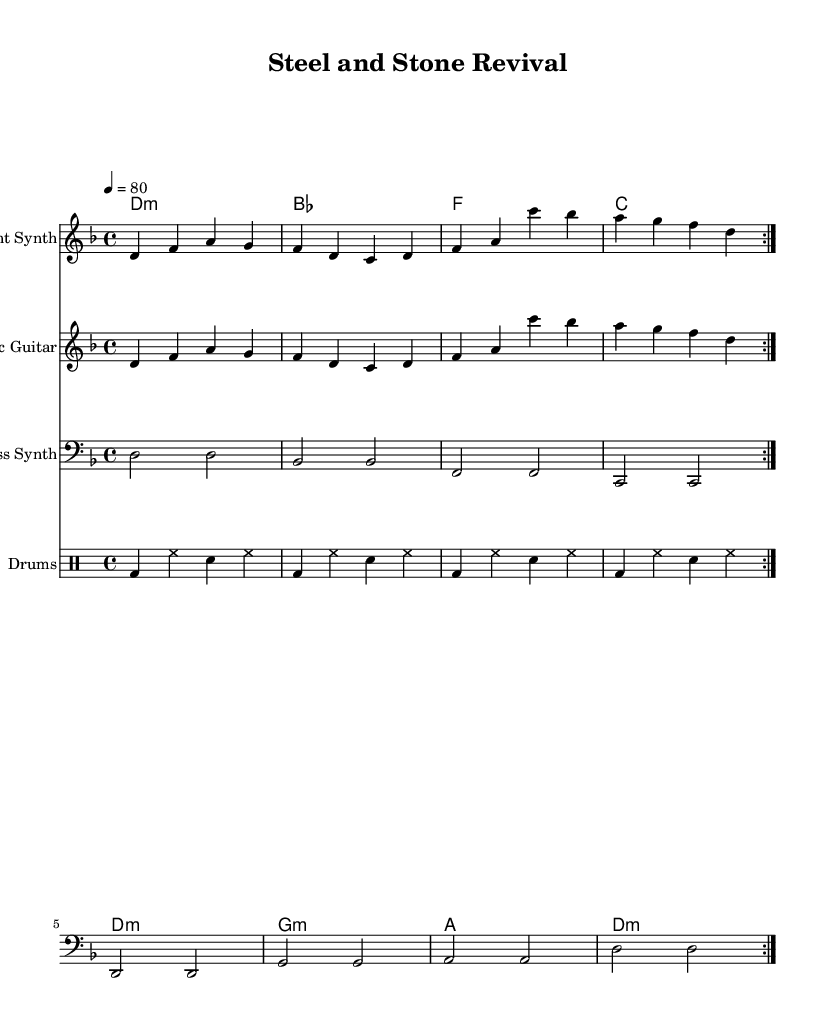What is the key signature of this music? The key signature shown is D minor, which has one flat (B♭).
Answer: D minor What is the time signature of the piece? The time signature displayed is 4/4, indicating four beats per measure.
Answer: 4/4 What is the tempo marking of the piece? The tempo marking indicates a speed of 80 beats per minute, as set at the beginning of the score.
Answer: 80 How many different instruments are featured in the score? The score has four distinct parts: Ambient Synth, Electric Guitar, Bass Synth, and Drums, each represented as separate staves.
Answer: Four What type of harmonic progression is present in the chords? The chord progression follows a common structure often seen in ambient and fusion music, providing a smooth transition between the harmonies.
Answer: Common structure Describe the role of the bass synth in this composition. The bass synth plays longer notes in a consistent pattern, providing a foundation for the harmonic structure and supporting the rhythm within the ambient setting.
Answer: Foundation What style does this music composition represent? The music represents an industrial-ambient fusion, characterized by its use of electronic instrumentation and atmospheric sounds, blending electronic elements with traditional rock instruments.
Answer: Industrial-ambient fusion 